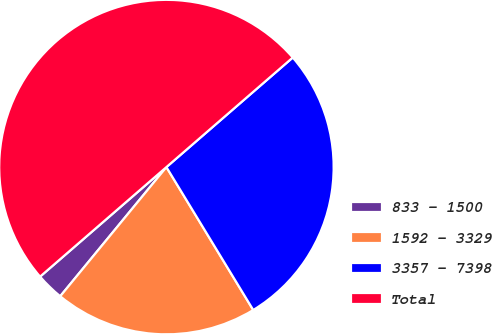<chart> <loc_0><loc_0><loc_500><loc_500><pie_chart><fcel>833 - 1500<fcel>1592 - 3329<fcel>3357 - 7398<fcel>Total<nl><fcel>2.68%<fcel>19.64%<fcel>27.68%<fcel>50.0%<nl></chart> 